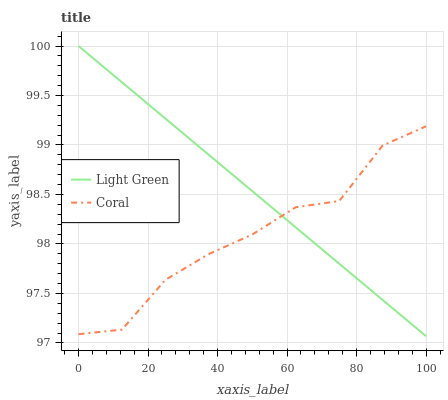Does Coral have the minimum area under the curve?
Answer yes or no. Yes. Does Light Green have the maximum area under the curve?
Answer yes or no. Yes. Does Light Green have the minimum area under the curve?
Answer yes or no. No. Is Light Green the smoothest?
Answer yes or no. Yes. Is Coral the roughest?
Answer yes or no. Yes. Is Light Green the roughest?
Answer yes or no. No. Does Light Green have the lowest value?
Answer yes or no. Yes. Does Light Green have the highest value?
Answer yes or no. Yes. Does Light Green intersect Coral?
Answer yes or no. Yes. Is Light Green less than Coral?
Answer yes or no. No. Is Light Green greater than Coral?
Answer yes or no. No. 